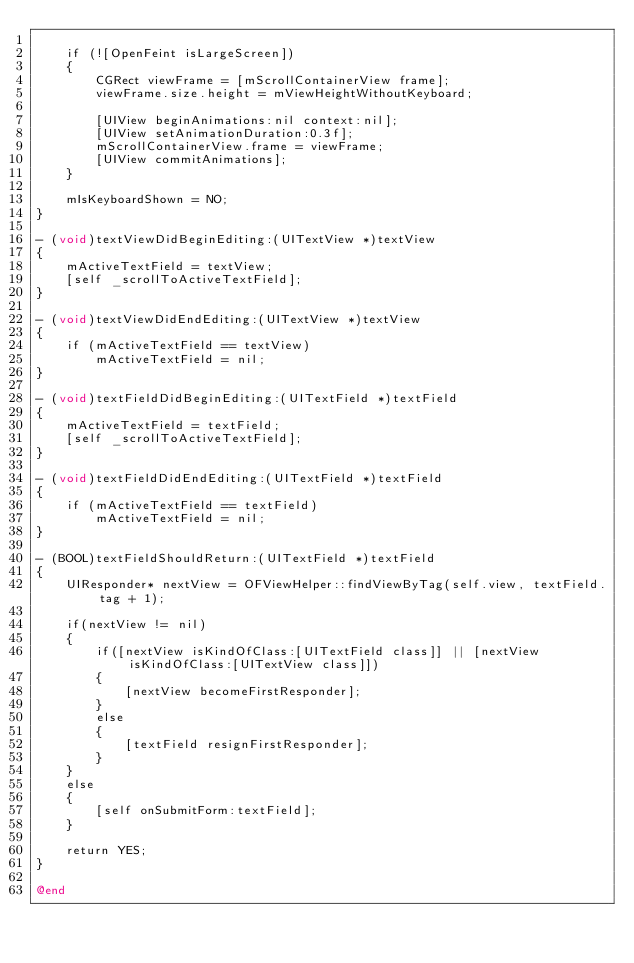<code> <loc_0><loc_0><loc_500><loc_500><_ObjectiveC_>
	if (![OpenFeint isLargeScreen])
	{
		CGRect viewFrame = [mScrollContainerView frame];
		viewFrame.size.height = mViewHeightWithoutKeyboard;

		[UIView beginAnimations:nil context:nil];
		[UIView setAnimationDuration:0.3f];		
		mScrollContainerView.frame = viewFrame;
		[UIView commitAnimations];
	}

    mIsKeyboardShown = NO;
}

- (void)textViewDidBeginEditing:(UITextView *)textView
{
	mActiveTextField = textView;
	[self _scrollToActiveTextField];
}

- (void)textViewDidEndEditing:(UITextView *)textView
{
	if (mActiveTextField == textView)
		mActiveTextField = nil;
}

- (void)textFieldDidBeginEditing:(UITextField *)textField
{
	mActiveTextField = textField;
	[self _scrollToActiveTextField];
}

- (void)textFieldDidEndEditing:(UITextField *)textField
{
	if (mActiveTextField == textField)
		mActiveTextField = nil;
}

- (BOOL)textFieldShouldReturn:(UITextField *)textField
{
	UIResponder* nextView = OFViewHelper::findViewByTag(self.view, textField.tag + 1);

	if(nextView != nil)
	{
		if([nextView isKindOfClass:[UITextField class]] || [nextView isKindOfClass:[UITextView class]])
		{
			[nextView becomeFirstResponder];
		}
		else
		{
			[textField resignFirstResponder];
		}
	}
	else
	{		
		[self onSubmitForm:textField];
	}
	
	return YES;
}

@end
</code> 